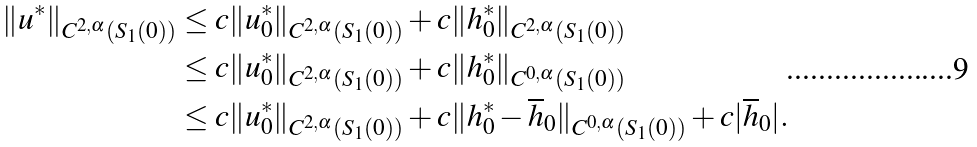Convert formula to latex. <formula><loc_0><loc_0><loc_500><loc_500>\| u ^ { * } \| _ { C ^ { 2 , \alpha } ( S _ { 1 } ( 0 ) ) } & \leq c \| u _ { 0 } ^ { * } \| _ { C ^ { 2 , \alpha } ( S _ { 1 } ( 0 ) ) } + c \| h _ { 0 } ^ { * } \| _ { C ^ { 2 , \alpha } ( S _ { 1 } ( 0 ) ) } \\ & \leq c \| u _ { 0 } ^ { * } \| _ { C ^ { 2 , \alpha } ( S _ { 1 } ( 0 ) ) } + c \| h _ { 0 } ^ { * } \| _ { C ^ { 0 , \alpha } ( S _ { 1 } ( 0 ) ) } \\ & \leq c \| u _ { 0 } ^ { * } \| _ { C ^ { 2 , \alpha } ( S _ { 1 } ( 0 ) ) } + c \| h _ { 0 } ^ { * } - \overline { h } _ { 0 } \| _ { C ^ { 0 , \alpha } ( S _ { 1 } ( 0 ) ) } + c | \overline { h } _ { 0 } | .</formula> 